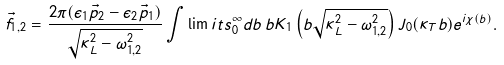Convert formula to latex. <formula><loc_0><loc_0><loc_500><loc_500>\vec { f } _ { 1 , 2 } = \frac { 2 \pi ( \epsilon _ { 1 } \vec { p } _ { 2 } - \epsilon _ { 2 } \vec { p } _ { 1 } ) } { \sqrt { \kappa _ { L } ^ { 2 } - \omega _ { 1 , 2 } ^ { 2 } } } \int \lim i t s _ { 0 } ^ { \infty } d b \, b K _ { 1 } \left ( b \sqrt { \kappa _ { L } ^ { 2 } - \omega _ { 1 , 2 } ^ { 2 } } \right ) J _ { 0 } ( \kappa _ { T } b ) e ^ { i \chi ( b ) } .</formula> 